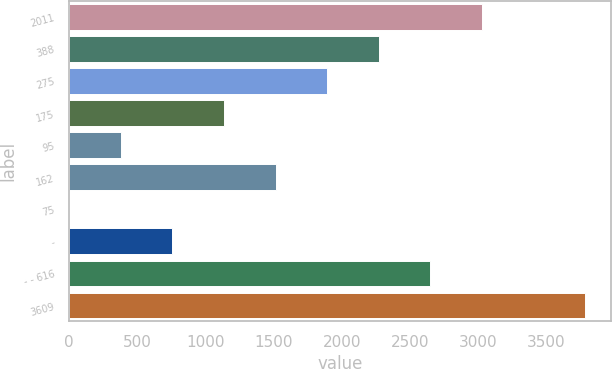<chart> <loc_0><loc_0><loc_500><loc_500><bar_chart><fcel>2011<fcel>388<fcel>275<fcel>175<fcel>95<fcel>162<fcel>75<fcel>-<fcel>- - 616<fcel>3609<nl><fcel>3027.6<fcel>2271.2<fcel>1893<fcel>1136.6<fcel>380.2<fcel>1514.8<fcel>2<fcel>758.4<fcel>2649.4<fcel>3784<nl></chart> 